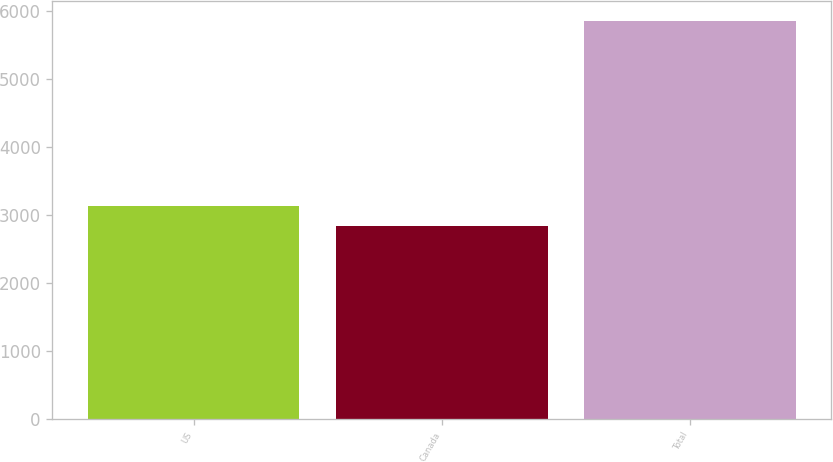<chart> <loc_0><loc_0><loc_500><loc_500><bar_chart><fcel>US<fcel>Canada<fcel>Total<nl><fcel>3140<fcel>2838<fcel>5858<nl></chart> 